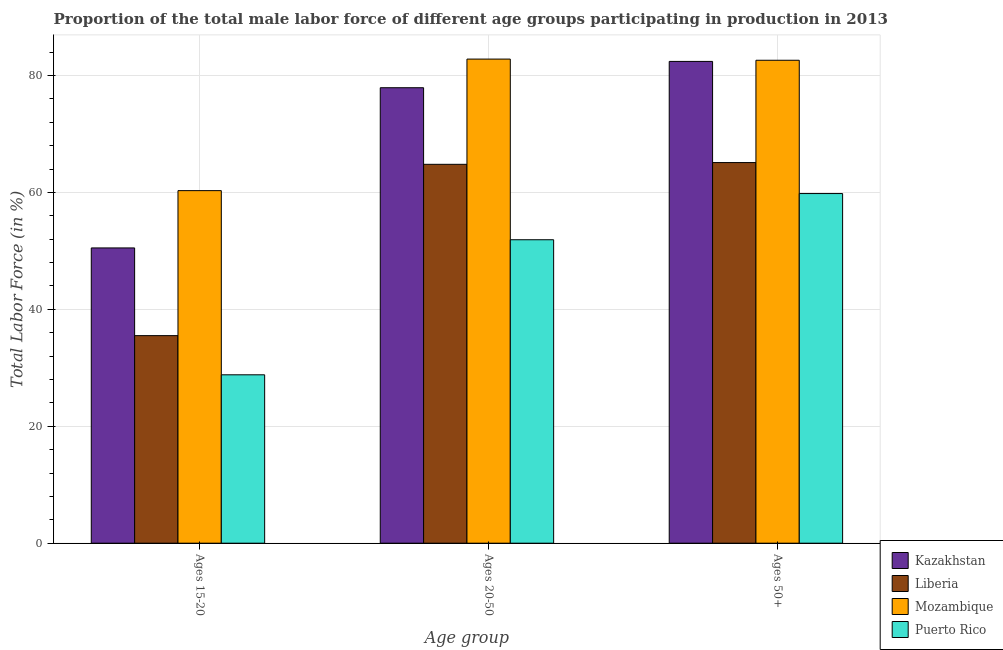How many different coloured bars are there?
Your answer should be compact. 4. Are the number of bars on each tick of the X-axis equal?
Give a very brief answer. Yes. How many bars are there on the 3rd tick from the left?
Provide a succinct answer. 4. What is the label of the 1st group of bars from the left?
Your answer should be very brief. Ages 15-20. What is the percentage of male labor force above age 50 in Puerto Rico?
Your response must be concise. 59.8. Across all countries, what is the maximum percentage of male labor force within the age group 15-20?
Provide a short and direct response. 60.3. Across all countries, what is the minimum percentage of male labor force above age 50?
Provide a succinct answer. 59.8. In which country was the percentage of male labor force within the age group 20-50 maximum?
Make the answer very short. Mozambique. In which country was the percentage of male labor force within the age group 15-20 minimum?
Give a very brief answer. Puerto Rico. What is the total percentage of male labor force within the age group 15-20 in the graph?
Keep it short and to the point. 175.1. What is the difference between the percentage of male labor force above age 50 in Mozambique and the percentage of male labor force within the age group 15-20 in Kazakhstan?
Provide a succinct answer. 32.1. What is the average percentage of male labor force within the age group 20-50 per country?
Provide a succinct answer. 69.35. What is the difference between the percentage of male labor force above age 50 and percentage of male labor force within the age group 15-20 in Mozambique?
Ensure brevity in your answer.  22.3. What is the ratio of the percentage of male labor force within the age group 15-20 in Mozambique to that in Kazakhstan?
Make the answer very short. 1.19. Is the percentage of male labor force within the age group 15-20 in Puerto Rico less than that in Kazakhstan?
Your answer should be compact. Yes. What is the difference between the highest and the second highest percentage of male labor force within the age group 20-50?
Make the answer very short. 4.9. What is the difference between the highest and the lowest percentage of male labor force within the age group 15-20?
Ensure brevity in your answer.  31.5. Is the sum of the percentage of male labor force above age 50 in Liberia and Kazakhstan greater than the maximum percentage of male labor force within the age group 20-50 across all countries?
Your answer should be compact. Yes. What does the 2nd bar from the left in Ages 15-20 represents?
Your answer should be compact. Liberia. What does the 3rd bar from the right in Ages 15-20 represents?
Provide a short and direct response. Liberia. Is it the case that in every country, the sum of the percentage of male labor force within the age group 15-20 and percentage of male labor force within the age group 20-50 is greater than the percentage of male labor force above age 50?
Ensure brevity in your answer.  Yes. How many bars are there?
Your answer should be very brief. 12. Are all the bars in the graph horizontal?
Provide a succinct answer. No. How many countries are there in the graph?
Provide a short and direct response. 4. What is the difference between two consecutive major ticks on the Y-axis?
Your answer should be compact. 20. Are the values on the major ticks of Y-axis written in scientific E-notation?
Your response must be concise. No. Does the graph contain grids?
Keep it short and to the point. Yes. Where does the legend appear in the graph?
Your response must be concise. Bottom right. What is the title of the graph?
Offer a terse response. Proportion of the total male labor force of different age groups participating in production in 2013. Does "Bangladesh" appear as one of the legend labels in the graph?
Make the answer very short. No. What is the label or title of the X-axis?
Keep it short and to the point. Age group. What is the label or title of the Y-axis?
Make the answer very short. Total Labor Force (in %). What is the Total Labor Force (in %) in Kazakhstan in Ages 15-20?
Your response must be concise. 50.5. What is the Total Labor Force (in %) in Liberia in Ages 15-20?
Ensure brevity in your answer.  35.5. What is the Total Labor Force (in %) of Mozambique in Ages 15-20?
Ensure brevity in your answer.  60.3. What is the Total Labor Force (in %) in Puerto Rico in Ages 15-20?
Your answer should be very brief. 28.8. What is the Total Labor Force (in %) of Kazakhstan in Ages 20-50?
Keep it short and to the point. 77.9. What is the Total Labor Force (in %) of Liberia in Ages 20-50?
Your response must be concise. 64.8. What is the Total Labor Force (in %) of Mozambique in Ages 20-50?
Give a very brief answer. 82.8. What is the Total Labor Force (in %) in Puerto Rico in Ages 20-50?
Your answer should be very brief. 51.9. What is the Total Labor Force (in %) of Kazakhstan in Ages 50+?
Offer a terse response. 82.4. What is the Total Labor Force (in %) of Liberia in Ages 50+?
Make the answer very short. 65.1. What is the Total Labor Force (in %) in Mozambique in Ages 50+?
Offer a terse response. 82.6. What is the Total Labor Force (in %) in Puerto Rico in Ages 50+?
Your answer should be compact. 59.8. Across all Age group, what is the maximum Total Labor Force (in %) in Kazakhstan?
Your response must be concise. 82.4. Across all Age group, what is the maximum Total Labor Force (in %) of Liberia?
Offer a very short reply. 65.1. Across all Age group, what is the maximum Total Labor Force (in %) in Mozambique?
Give a very brief answer. 82.8. Across all Age group, what is the maximum Total Labor Force (in %) in Puerto Rico?
Give a very brief answer. 59.8. Across all Age group, what is the minimum Total Labor Force (in %) of Kazakhstan?
Offer a terse response. 50.5. Across all Age group, what is the minimum Total Labor Force (in %) of Liberia?
Offer a terse response. 35.5. Across all Age group, what is the minimum Total Labor Force (in %) in Mozambique?
Ensure brevity in your answer.  60.3. Across all Age group, what is the minimum Total Labor Force (in %) in Puerto Rico?
Offer a very short reply. 28.8. What is the total Total Labor Force (in %) of Kazakhstan in the graph?
Keep it short and to the point. 210.8. What is the total Total Labor Force (in %) of Liberia in the graph?
Offer a very short reply. 165.4. What is the total Total Labor Force (in %) in Mozambique in the graph?
Give a very brief answer. 225.7. What is the total Total Labor Force (in %) in Puerto Rico in the graph?
Your response must be concise. 140.5. What is the difference between the Total Labor Force (in %) in Kazakhstan in Ages 15-20 and that in Ages 20-50?
Provide a succinct answer. -27.4. What is the difference between the Total Labor Force (in %) in Liberia in Ages 15-20 and that in Ages 20-50?
Your answer should be very brief. -29.3. What is the difference between the Total Labor Force (in %) in Mozambique in Ages 15-20 and that in Ages 20-50?
Make the answer very short. -22.5. What is the difference between the Total Labor Force (in %) in Puerto Rico in Ages 15-20 and that in Ages 20-50?
Your response must be concise. -23.1. What is the difference between the Total Labor Force (in %) of Kazakhstan in Ages 15-20 and that in Ages 50+?
Make the answer very short. -31.9. What is the difference between the Total Labor Force (in %) in Liberia in Ages 15-20 and that in Ages 50+?
Ensure brevity in your answer.  -29.6. What is the difference between the Total Labor Force (in %) in Mozambique in Ages 15-20 and that in Ages 50+?
Your response must be concise. -22.3. What is the difference between the Total Labor Force (in %) in Puerto Rico in Ages 15-20 and that in Ages 50+?
Your response must be concise. -31. What is the difference between the Total Labor Force (in %) of Puerto Rico in Ages 20-50 and that in Ages 50+?
Your answer should be compact. -7.9. What is the difference between the Total Labor Force (in %) in Kazakhstan in Ages 15-20 and the Total Labor Force (in %) in Liberia in Ages 20-50?
Offer a very short reply. -14.3. What is the difference between the Total Labor Force (in %) in Kazakhstan in Ages 15-20 and the Total Labor Force (in %) in Mozambique in Ages 20-50?
Provide a short and direct response. -32.3. What is the difference between the Total Labor Force (in %) in Liberia in Ages 15-20 and the Total Labor Force (in %) in Mozambique in Ages 20-50?
Your response must be concise. -47.3. What is the difference between the Total Labor Force (in %) of Liberia in Ages 15-20 and the Total Labor Force (in %) of Puerto Rico in Ages 20-50?
Your answer should be compact. -16.4. What is the difference between the Total Labor Force (in %) of Mozambique in Ages 15-20 and the Total Labor Force (in %) of Puerto Rico in Ages 20-50?
Make the answer very short. 8.4. What is the difference between the Total Labor Force (in %) in Kazakhstan in Ages 15-20 and the Total Labor Force (in %) in Liberia in Ages 50+?
Make the answer very short. -14.6. What is the difference between the Total Labor Force (in %) in Kazakhstan in Ages 15-20 and the Total Labor Force (in %) in Mozambique in Ages 50+?
Offer a terse response. -32.1. What is the difference between the Total Labor Force (in %) in Kazakhstan in Ages 15-20 and the Total Labor Force (in %) in Puerto Rico in Ages 50+?
Your response must be concise. -9.3. What is the difference between the Total Labor Force (in %) of Liberia in Ages 15-20 and the Total Labor Force (in %) of Mozambique in Ages 50+?
Ensure brevity in your answer.  -47.1. What is the difference between the Total Labor Force (in %) of Liberia in Ages 15-20 and the Total Labor Force (in %) of Puerto Rico in Ages 50+?
Provide a short and direct response. -24.3. What is the difference between the Total Labor Force (in %) in Mozambique in Ages 15-20 and the Total Labor Force (in %) in Puerto Rico in Ages 50+?
Offer a very short reply. 0.5. What is the difference between the Total Labor Force (in %) in Kazakhstan in Ages 20-50 and the Total Labor Force (in %) in Puerto Rico in Ages 50+?
Give a very brief answer. 18.1. What is the difference between the Total Labor Force (in %) of Liberia in Ages 20-50 and the Total Labor Force (in %) of Mozambique in Ages 50+?
Ensure brevity in your answer.  -17.8. What is the difference between the Total Labor Force (in %) in Liberia in Ages 20-50 and the Total Labor Force (in %) in Puerto Rico in Ages 50+?
Your response must be concise. 5. What is the average Total Labor Force (in %) in Kazakhstan per Age group?
Provide a succinct answer. 70.27. What is the average Total Labor Force (in %) in Liberia per Age group?
Your answer should be compact. 55.13. What is the average Total Labor Force (in %) of Mozambique per Age group?
Provide a succinct answer. 75.23. What is the average Total Labor Force (in %) of Puerto Rico per Age group?
Your response must be concise. 46.83. What is the difference between the Total Labor Force (in %) of Kazakhstan and Total Labor Force (in %) of Liberia in Ages 15-20?
Provide a succinct answer. 15. What is the difference between the Total Labor Force (in %) in Kazakhstan and Total Labor Force (in %) in Puerto Rico in Ages 15-20?
Provide a succinct answer. 21.7. What is the difference between the Total Labor Force (in %) of Liberia and Total Labor Force (in %) of Mozambique in Ages 15-20?
Keep it short and to the point. -24.8. What is the difference between the Total Labor Force (in %) of Liberia and Total Labor Force (in %) of Puerto Rico in Ages 15-20?
Give a very brief answer. 6.7. What is the difference between the Total Labor Force (in %) of Mozambique and Total Labor Force (in %) of Puerto Rico in Ages 15-20?
Offer a very short reply. 31.5. What is the difference between the Total Labor Force (in %) in Kazakhstan and Total Labor Force (in %) in Liberia in Ages 20-50?
Offer a very short reply. 13.1. What is the difference between the Total Labor Force (in %) of Kazakhstan and Total Labor Force (in %) of Puerto Rico in Ages 20-50?
Make the answer very short. 26. What is the difference between the Total Labor Force (in %) in Mozambique and Total Labor Force (in %) in Puerto Rico in Ages 20-50?
Give a very brief answer. 30.9. What is the difference between the Total Labor Force (in %) in Kazakhstan and Total Labor Force (in %) in Puerto Rico in Ages 50+?
Offer a very short reply. 22.6. What is the difference between the Total Labor Force (in %) of Liberia and Total Labor Force (in %) of Mozambique in Ages 50+?
Offer a terse response. -17.5. What is the difference between the Total Labor Force (in %) of Mozambique and Total Labor Force (in %) of Puerto Rico in Ages 50+?
Provide a succinct answer. 22.8. What is the ratio of the Total Labor Force (in %) in Kazakhstan in Ages 15-20 to that in Ages 20-50?
Keep it short and to the point. 0.65. What is the ratio of the Total Labor Force (in %) of Liberia in Ages 15-20 to that in Ages 20-50?
Provide a succinct answer. 0.55. What is the ratio of the Total Labor Force (in %) of Mozambique in Ages 15-20 to that in Ages 20-50?
Keep it short and to the point. 0.73. What is the ratio of the Total Labor Force (in %) of Puerto Rico in Ages 15-20 to that in Ages 20-50?
Ensure brevity in your answer.  0.55. What is the ratio of the Total Labor Force (in %) in Kazakhstan in Ages 15-20 to that in Ages 50+?
Your response must be concise. 0.61. What is the ratio of the Total Labor Force (in %) of Liberia in Ages 15-20 to that in Ages 50+?
Give a very brief answer. 0.55. What is the ratio of the Total Labor Force (in %) of Mozambique in Ages 15-20 to that in Ages 50+?
Your answer should be compact. 0.73. What is the ratio of the Total Labor Force (in %) of Puerto Rico in Ages 15-20 to that in Ages 50+?
Offer a very short reply. 0.48. What is the ratio of the Total Labor Force (in %) in Kazakhstan in Ages 20-50 to that in Ages 50+?
Keep it short and to the point. 0.95. What is the ratio of the Total Labor Force (in %) in Puerto Rico in Ages 20-50 to that in Ages 50+?
Ensure brevity in your answer.  0.87. What is the difference between the highest and the lowest Total Labor Force (in %) in Kazakhstan?
Make the answer very short. 31.9. What is the difference between the highest and the lowest Total Labor Force (in %) in Liberia?
Your answer should be compact. 29.6. What is the difference between the highest and the lowest Total Labor Force (in %) in Puerto Rico?
Your response must be concise. 31. 